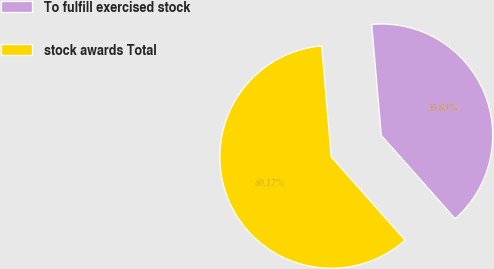Convert chart to OTSL. <chart><loc_0><loc_0><loc_500><loc_500><pie_chart><fcel>To fulfill exercised stock<fcel>stock awards Total<nl><fcel>39.83%<fcel>60.17%<nl></chart> 